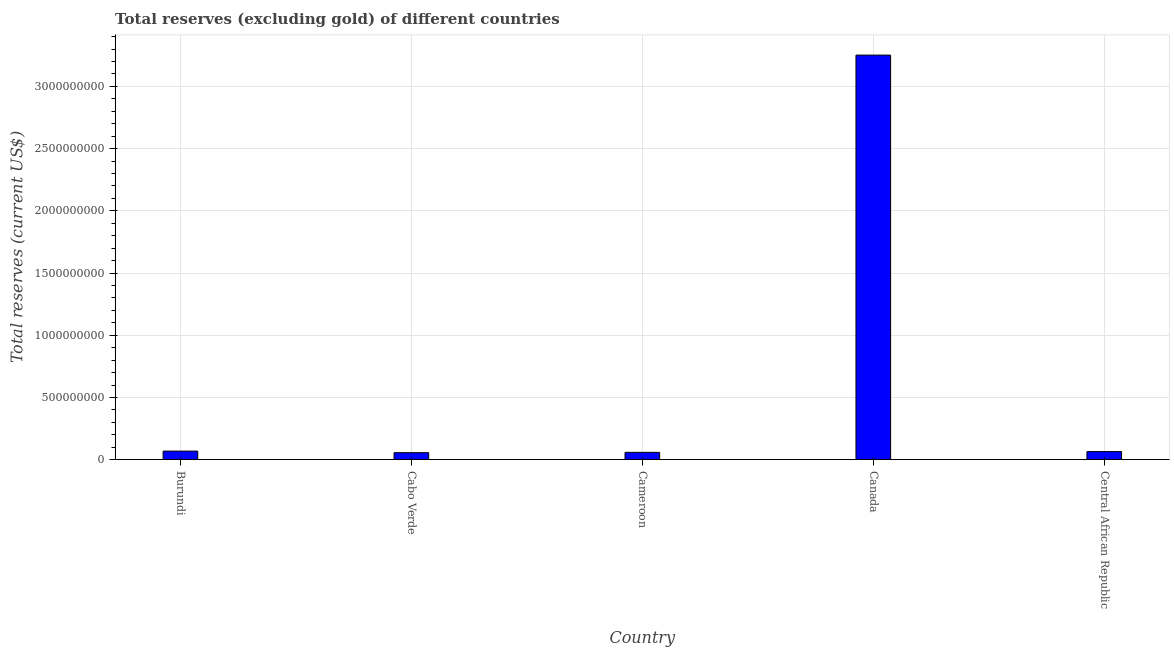Does the graph contain grids?
Offer a terse response. Yes. What is the title of the graph?
Offer a very short reply. Total reserves (excluding gold) of different countries. What is the label or title of the Y-axis?
Your answer should be very brief. Total reserves (current US$). What is the total reserves (excluding gold) in Canada?
Keep it short and to the point. 3.25e+09. Across all countries, what is the maximum total reserves (excluding gold)?
Your answer should be compact. 3.25e+09. Across all countries, what is the minimum total reserves (excluding gold)?
Give a very brief answer. 5.64e+07. In which country was the total reserves (excluding gold) maximum?
Ensure brevity in your answer.  Canada. In which country was the total reserves (excluding gold) minimum?
Provide a succinct answer. Cabo Verde. What is the sum of the total reserves (excluding gold)?
Your answer should be very brief. 3.50e+09. What is the difference between the total reserves (excluding gold) in Burundi and Canada?
Your answer should be compact. -3.18e+09. What is the average total reserves (excluding gold) per country?
Keep it short and to the point. 7.00e+08. What is the median total reserves (excluding gold)?
Offer a terse response. 6.54e+07. In how many countries, is the total reserves (excluding gold) greater than 2200000000 US$?
Offer a very short reply. 1. What is the ratio of the total reserves (excluding gold) in Cameroon to that in Canada?
Your response must be concise. 0.02. What is the difference between the highest and the second highest total reserves (excluding gold)?
Offer a very short reply. 3.18e+09. Is the sum of the total reserves (excluding gold) in Cameroon and Central African Republic greater than the maximum total reserves (excluding gold) across all countries?
Make the answer very short. No. What is the difference between the highest and the lowest total reserves (excluding gold)?
Your answer should be compact. 3.19e+09. What is the difference between two consecutive major ticks on the Y-axis?
Offer a very short reply. 5.00e+08. What is the Total reserves (current US$) of Burundi?
Your answer should be very brief. 6.91e+07. What is the Total reserves (current US$) of Cabo Verde?
Keep it short and to the point. 5.64e+07. What is the Total reserves (current US$) in Cameroon?
Offer a terse response. 5.90e+07. What is the Total reserves (current US$) of Canada?
Your answer should be compact. 3.25e+09. What is the Total reserves (current US$) in Central African Republic?
Your response must be concise. 6.54e+07. What is the difference between the Total reserves (current US$) in Burundi and Cabo Verde?
Ensure brevity in your answer.  1.27e+07. What is the difference between the Total reserves (current US$) in Burundi and Cameroon?
Make the answer very short. 1.01e+07. What is the difference between the Total reserves (current US$) in Burundi and Canada?
Provide a short and direct response. -3.18e+09. What is the difference between the Total reserves (current US$) in Burundi and Central African Republic?
Provide a short and direct response. 3.72e+06. What is the difference between the Total reserves (current US$) in Cabo Verde and Cameroon?
Offer a terse response. -2.66e+06. What is the difference between the Total reserves (current US$) in Cabo Verde and Canada?
Provide a short and direct response. -3.19e+09. What is the difference between the Total reserves (current US$) in Cabo Verde and Central African Republic?
Your answer should be very brief. -9.00e+06. What is the difference between the Total reserves (current US$) in Cameroon and Canada?
Provide a short and direct response. -3.19e+09. What is the difference between the Total reserves (current US$) in Cameroon and Central African Republic?
Your response must be concise. -6.34e+06. What is the difference between the Total reserves (current US$) in Canada and Central African Republic?
Offer a terse response. 3.19e+09. What is the ratio of the Total reserves (current US$) in Burundi to that in Cabo Verde?
Offer a terse response. 1.23. What is the ratio of the Total reserves (current US$) in Burundi to that in Cameroon?
Give a very brief answer. 1.17. What is the ratio of the Total reserves (current US$) in Burundi to that in Canada?
Make the answer very short. 0.02. What is the ratio of the Total reserves (current US$) in Burundi to that in Central African Republic?
Your answer should be very brief. 1.06. What is the ratio of the Total reserves (current US$) in Cabo Verde to that in Cameroon?
Offer a terse response. 0.95. What is the ratio of the Total reserves (current US$) in Cabo Verde to that in Canada?
Offer a very short reply. 0.02. What is the ratio of the Total reserves (current US$) in Cabo Verde to that in Central African Republic?
Offer a very short reply. 0.86. What is the ratio of the Total reserves (current US$) in Cameroon to that in Canada?
Ensure brevity in your answer.  0.02. What is the ratio of the Total reserves (current US$) in Cameroon to that in Central African Republic?
Offer a very short reply. 0.9. What is the ratio of the Total reserves (current US$) in Canada to that in Central African Republic?
Offer a very short reply. 49.75. 